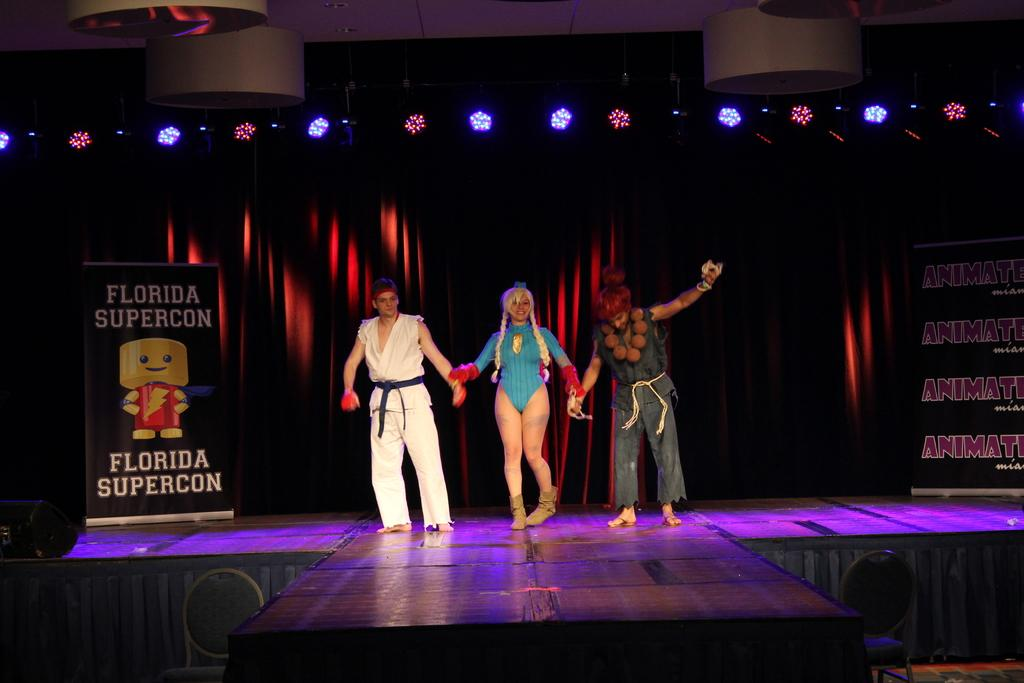<image>
Provide a brief description of the given image. Three people in anime costumes are walking down a stage by a sign that says Florida Supercon. 